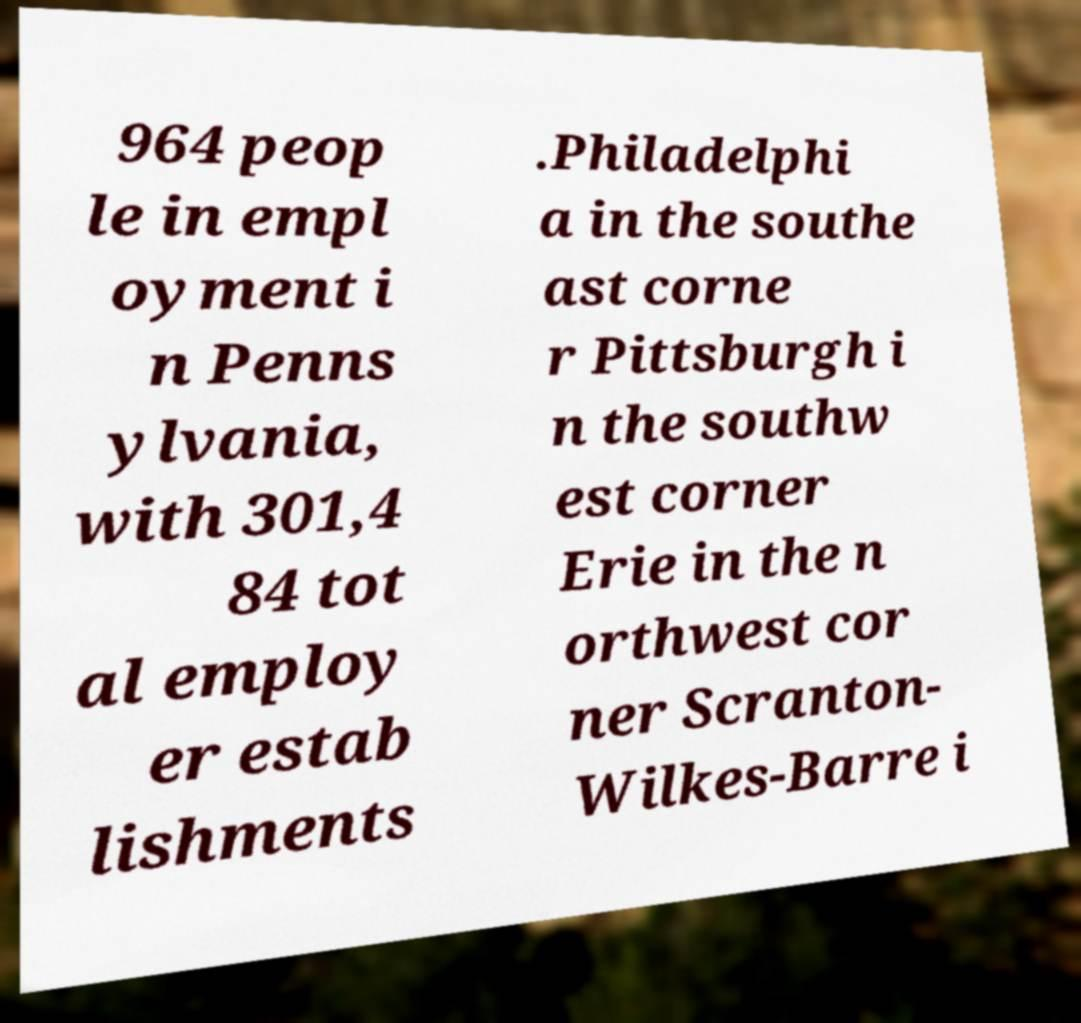Could you assist in decoding the text presented in this image and type it out clearly? 964 peop le in empl oyment i n Penns ylvania, with 301,4 84 tot al employ er estab lishments .Philadelphi a in the southe ast corne r Pittsburgh i n the southw est corner Erie in the n orthwest cor ner Scranton- Wilkes-Barre i 